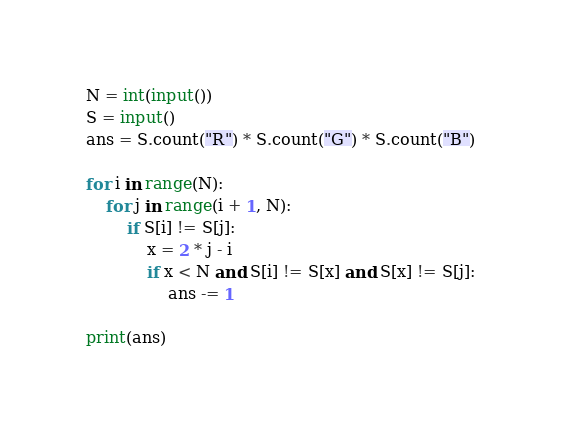<code> <loc_0><loc_0><loc_500><loc_500><_Python_>N = int(input())
S = input()
ans = S.count("R") * S.count("G") * S.count("B")

for i in range(N):
    for j in range(i + 1, N):
        if S[i] != S[j]:
            x = 2 * j - i
            if x < N and S[i] != S[x] and S[x] != S[j]:
                ans -= 1

print(ans)
</code> 